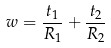<formula> <loc_0><loc_0><loc_500><loc_500>w = \frac { t _ { 1 } } { R _ { 1 } } + \frac { t _ { 2 } } { R _ { 2 } }</formula> 